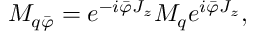<formula> <loc_0><loc_0><loc_500><loc_500>M _ { q \bar { \varphi } } = e ^ { - i \bar { \varphi } J _ { z } } M _ { q } e ^ { i \bar { \varphi } J _ { z } } ,</formula> 